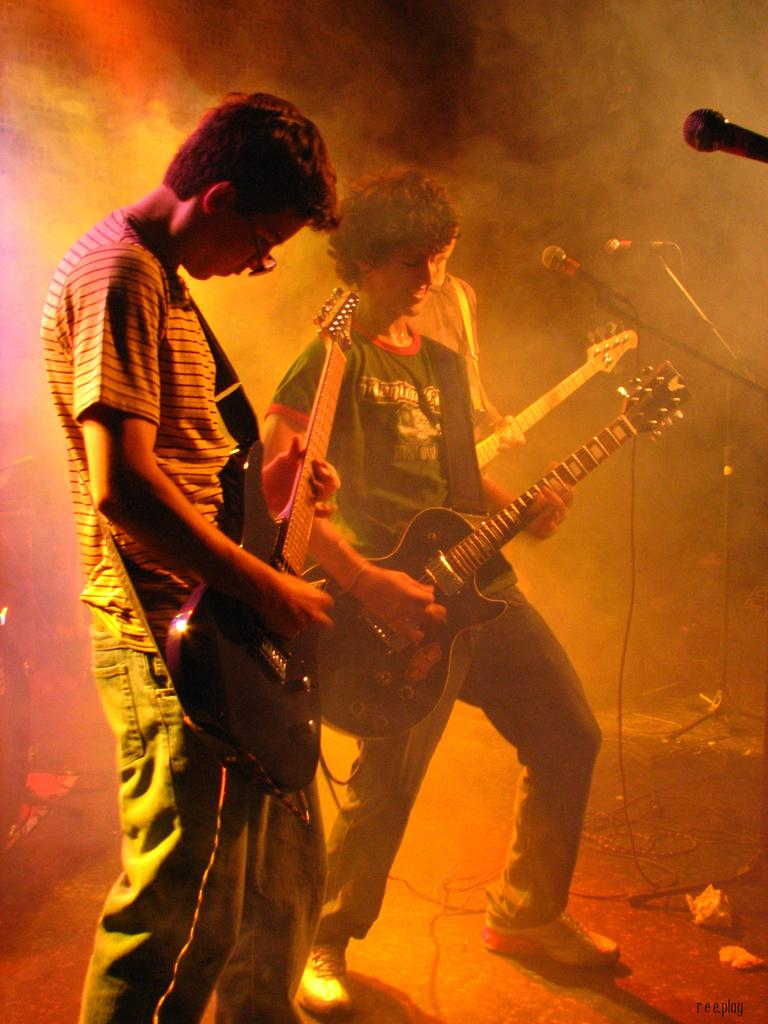How many people are in the image? There are three persons in the image. What are the persons doing in the image? The three persons are playing the guitar. What object is in front of the persons? There is a microphone in front of the persons. What type of cushion is being used by the brother to support the guitar in the image? There is no cushion or brother present in the image, and the guitar is being played without any visible support. 